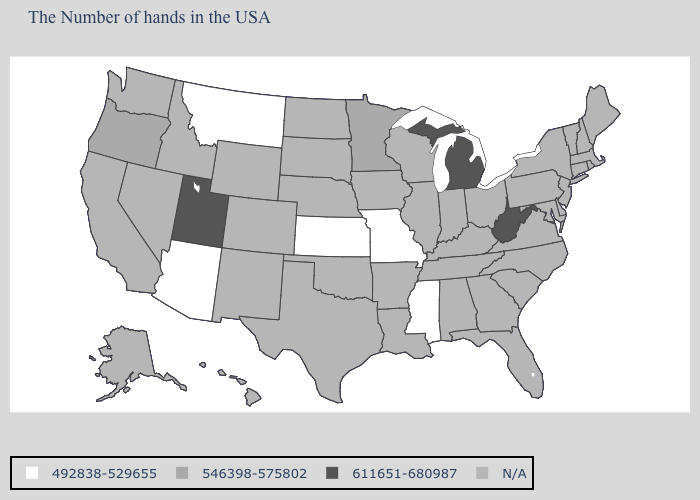What is the value of Montana?
Give a very brief answer. 492838-529655. Name the states that have a value in the range 611651-680987?
Keep it brief. West Virginia, Michigan, Utah. What is the value of Wyoming?
Keep it brief. N/A. What is the value of Hawaii?
Keep it brief. N/A. Name the states that have a value in the range 611651-680987?
Quick response, please. West Virginia, Michigan, Utah. Name the states that have a value in the range 611651-680987?
Write a very short answer. West Virginia, Michigan, Utah. What is the lowest value in the USA?
Quick response, please. 492838-529655. Which states have the highest value in the USA?
Quick response, please. West Virginia, Michigan, Utah. Name the states that have a value in the range 492838-529655?
Write a very short answer. Mississippi, Missouri, Kansas, Montana, Arizona. Among the states that border Missouri , which have the lowest value?
Be succinct. Kansas. What is the lowest value in the West?
Answer briefly. 492838-529655. What is the lowest value in the USA?
Write a very short answer. 492838-529655. 